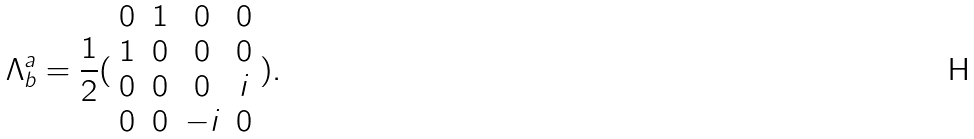<formula> <loc_0><loc_0><loc_500><loc_500>\Lambda _ { b } ^ { a } = \frac { 1 } { 2 } ( \begin{array} { c c c c } 0 & 1 & 0 & 0 \\ 1 & 0 & 0 & 0 \\ 0 & 0 & 0 & i \\ 0 & 0 & - i & 0 \end{array} ) .</formula> 